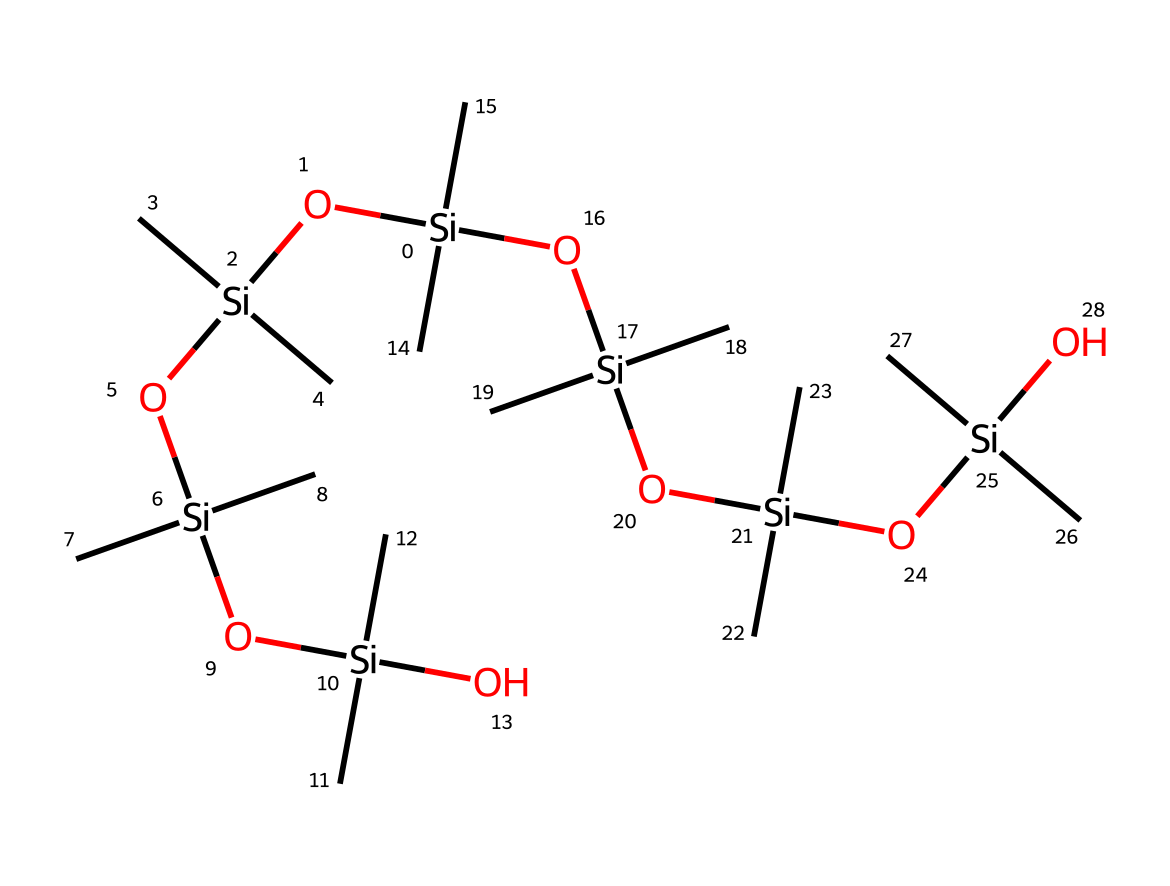What type of chemical is represented by the SMILES? The structure shows silicons, indicating it is a silicone compound.
Answer: silicone How many silicon atoms are in the structure? By analyzing the SMILES notation, we count five instances of "Si," which indicates there are five silicon atoms.
Answer: five What functional groups are present in this molecule? The presence of "O," suggests hydroxyl groups or silanol groups are present, as these are connected to silicon atoms.
Answer: hydroxyl groups What is the significance of the methyl groups in the structure? The "C" notation indicates the presence of methyl groups attached to silicon, which contributes to the hydrophobic properties of the silicone sealant.
Answer: hydrophobic properties How does the branching in the structure affect its properties? The branched aliphatic structure allows for flexibility and adhesion in sealant applications, enhancing seal quality in joints.
Answer: flexibility How many total oxygen atoms are present in the structure? Inspecting the SMILES, we can identify six instances of "O," signifying that there are six oxygen atoms in total.
Answer: six What type of bonding is primarily associated with silicone sealants? The structure prominently features Si-O bonds, characteristic of silicone polymers, leading to unique mechanical properties.
Answer: Si-O bonds 